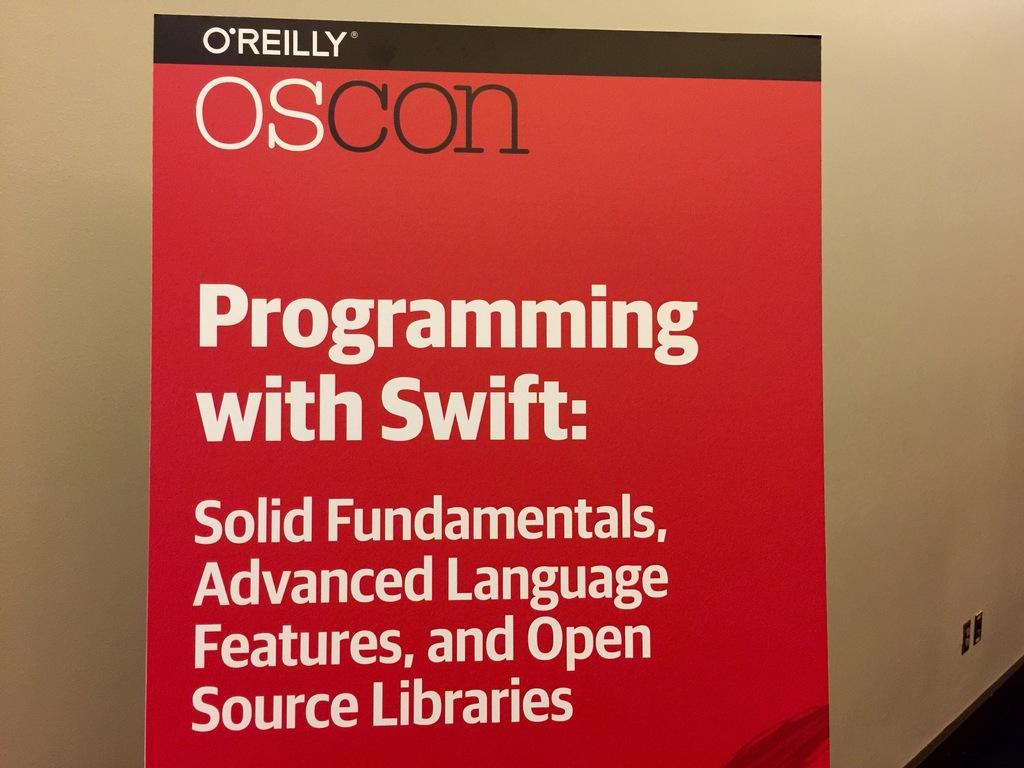Is this poster about programming?
Ensure brevity in your answer.  Yes. 